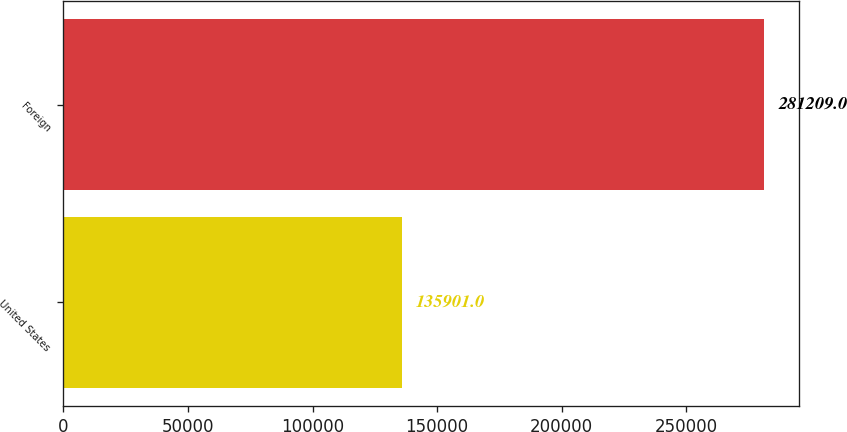Convert chart. <chart><loc_0><loc_0><loc_500><loc_500><bar_chart><fcel>United States<fcel>Foreign<nl><fcel>135901<fcel>281209<nl></chart> 